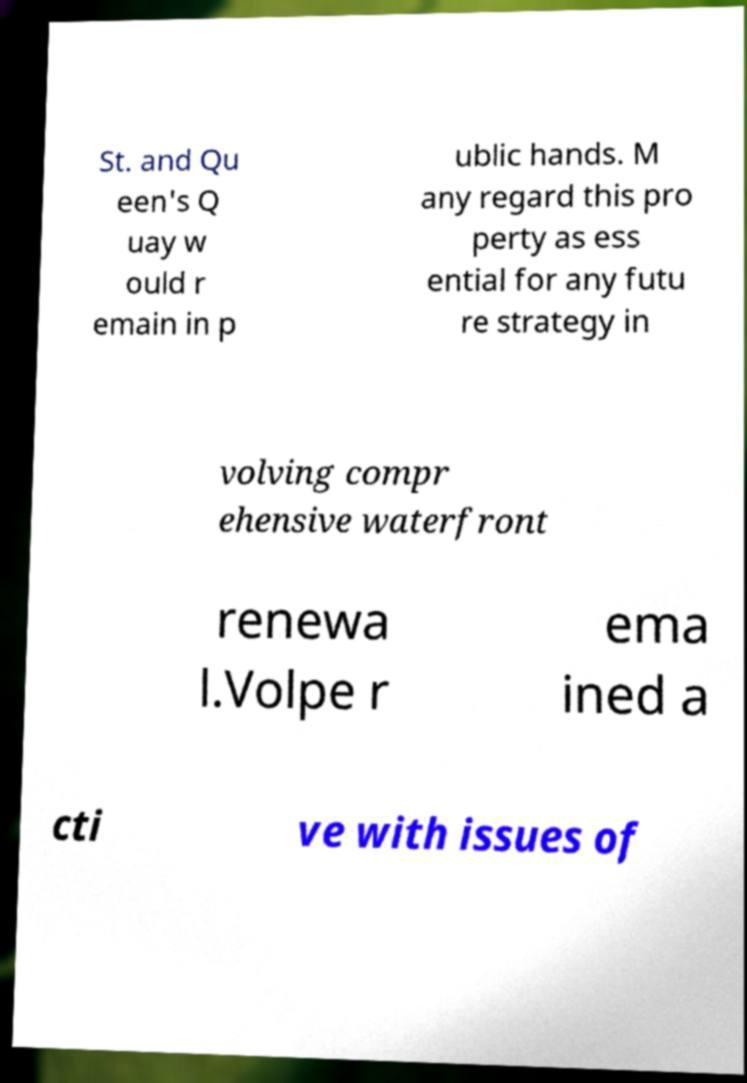There's text embedded in this image that I need extracted. Can you transcribe it verbatim? St. and Qu een's Q uay w ould r emain in p ublic hands. M any regard this pro perty as ess ential for any futu re strategy in volving compr ehensive waterfront renewa l.Volpe r ema ined a cti ve with issues of 